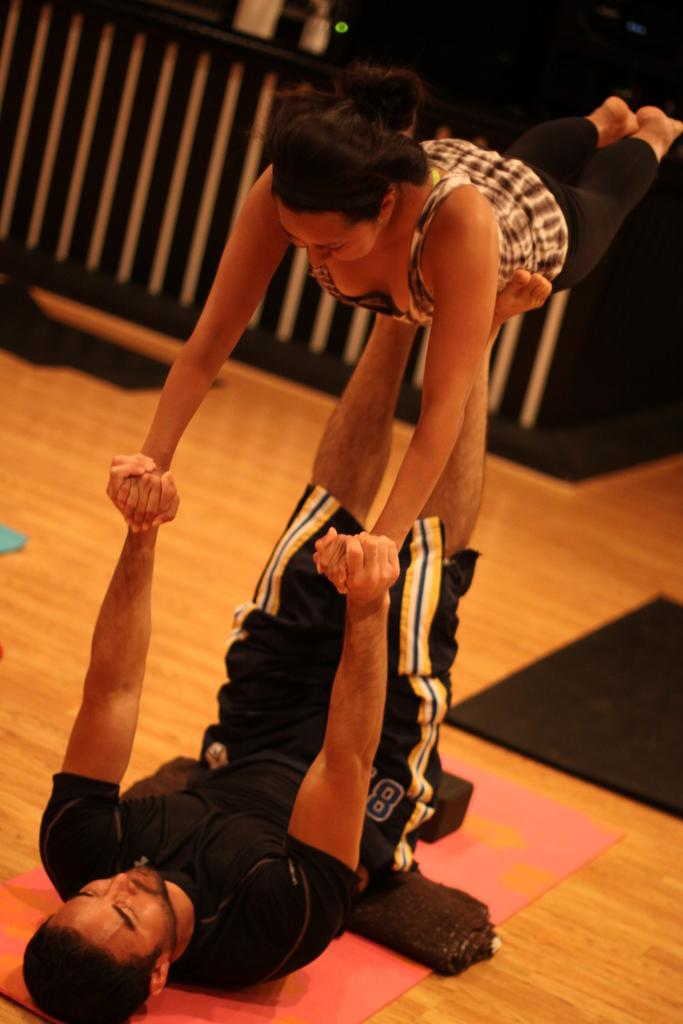Who are the two people in the image? There is a man and a woman in the image. What are they doing in the image? They are performing on a mat. Where is the mat located in the image? The mat is on the floor. What can be seen in the background of the image? There is a fence in the background of the image, and the background is dark in color. What type of pollution can be seen in the image? There is no pollution visible in the image; it features a man and a woman performing on a mat with a dark background and a fence in the distance. 